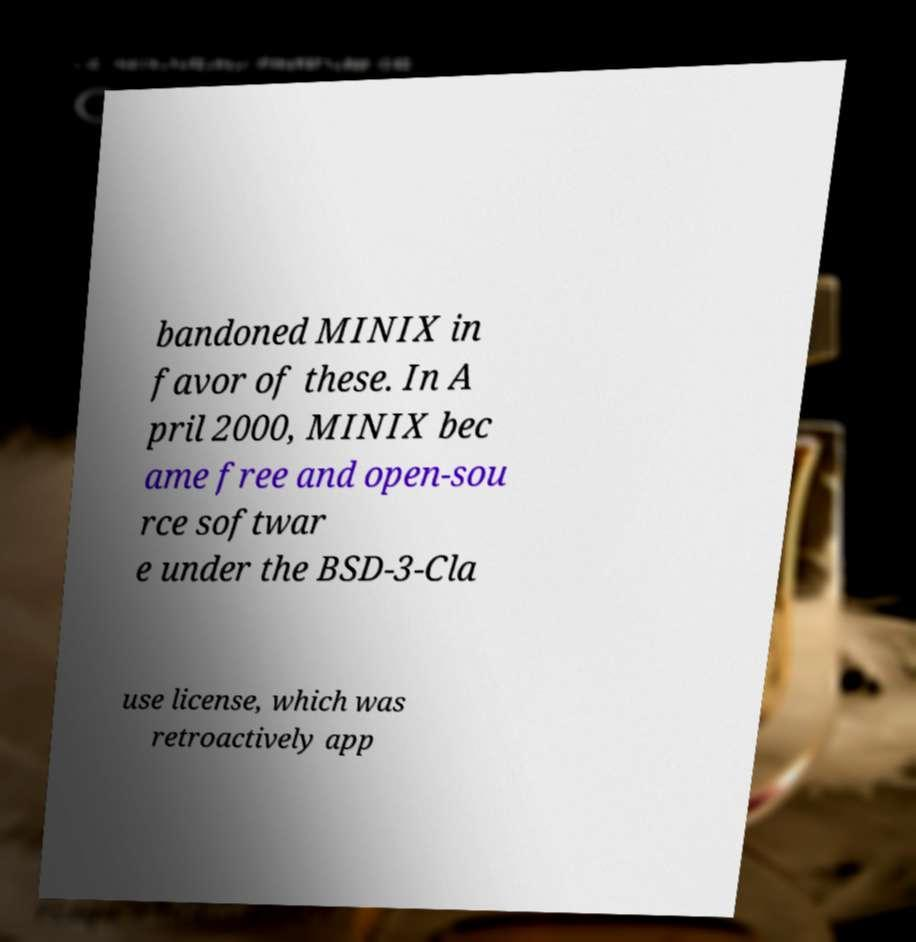Could you extract and type out the text from this image? bandoned MINIX in favor of these. In A pril 2000, MINIX bec ame free and open-sou rce softwar e under the BSD-3-Cla use license, which was retroactively app 